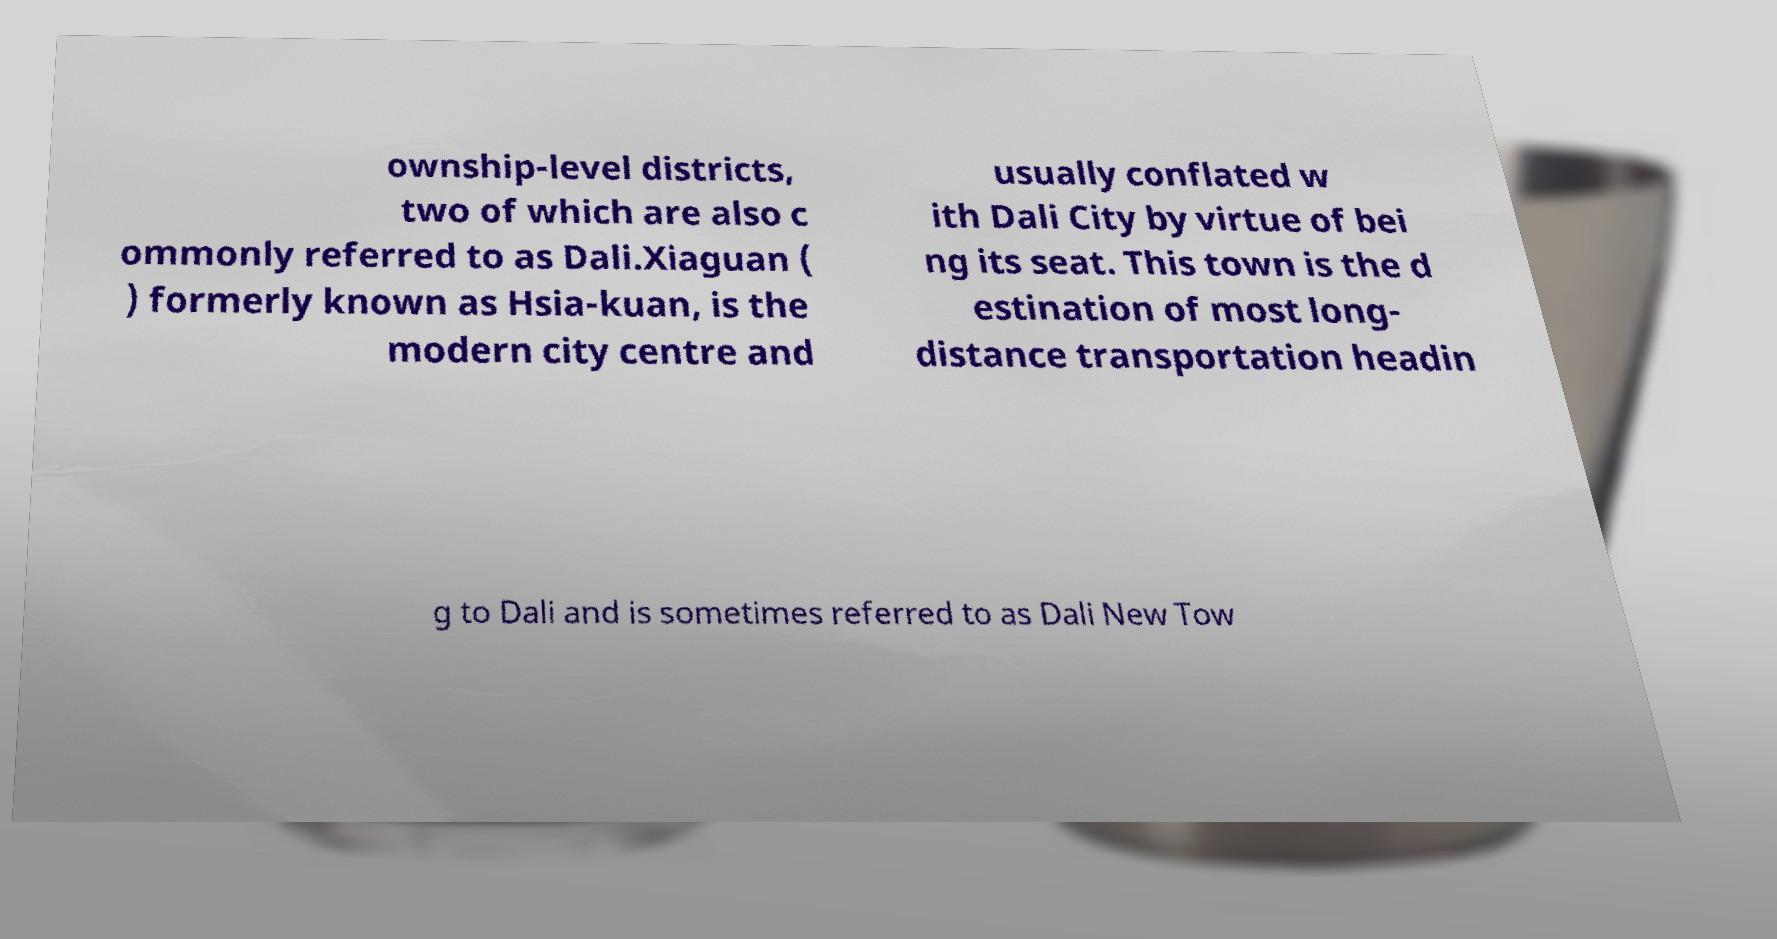For documentation purposes, I need the text within this image transcribed. Could you provide that? ownship-level districts, two of which are also c ommonly referred to as Dali.Xiaguan ( ) formerly known as Hsia-kuan, is the modern city centre and usually conflated w ith Dali City by virtue of bei ng its seat. This town is the d estination of most long- distance transportation headin g to Dali and is sometimes referred to as Dali New Tow 